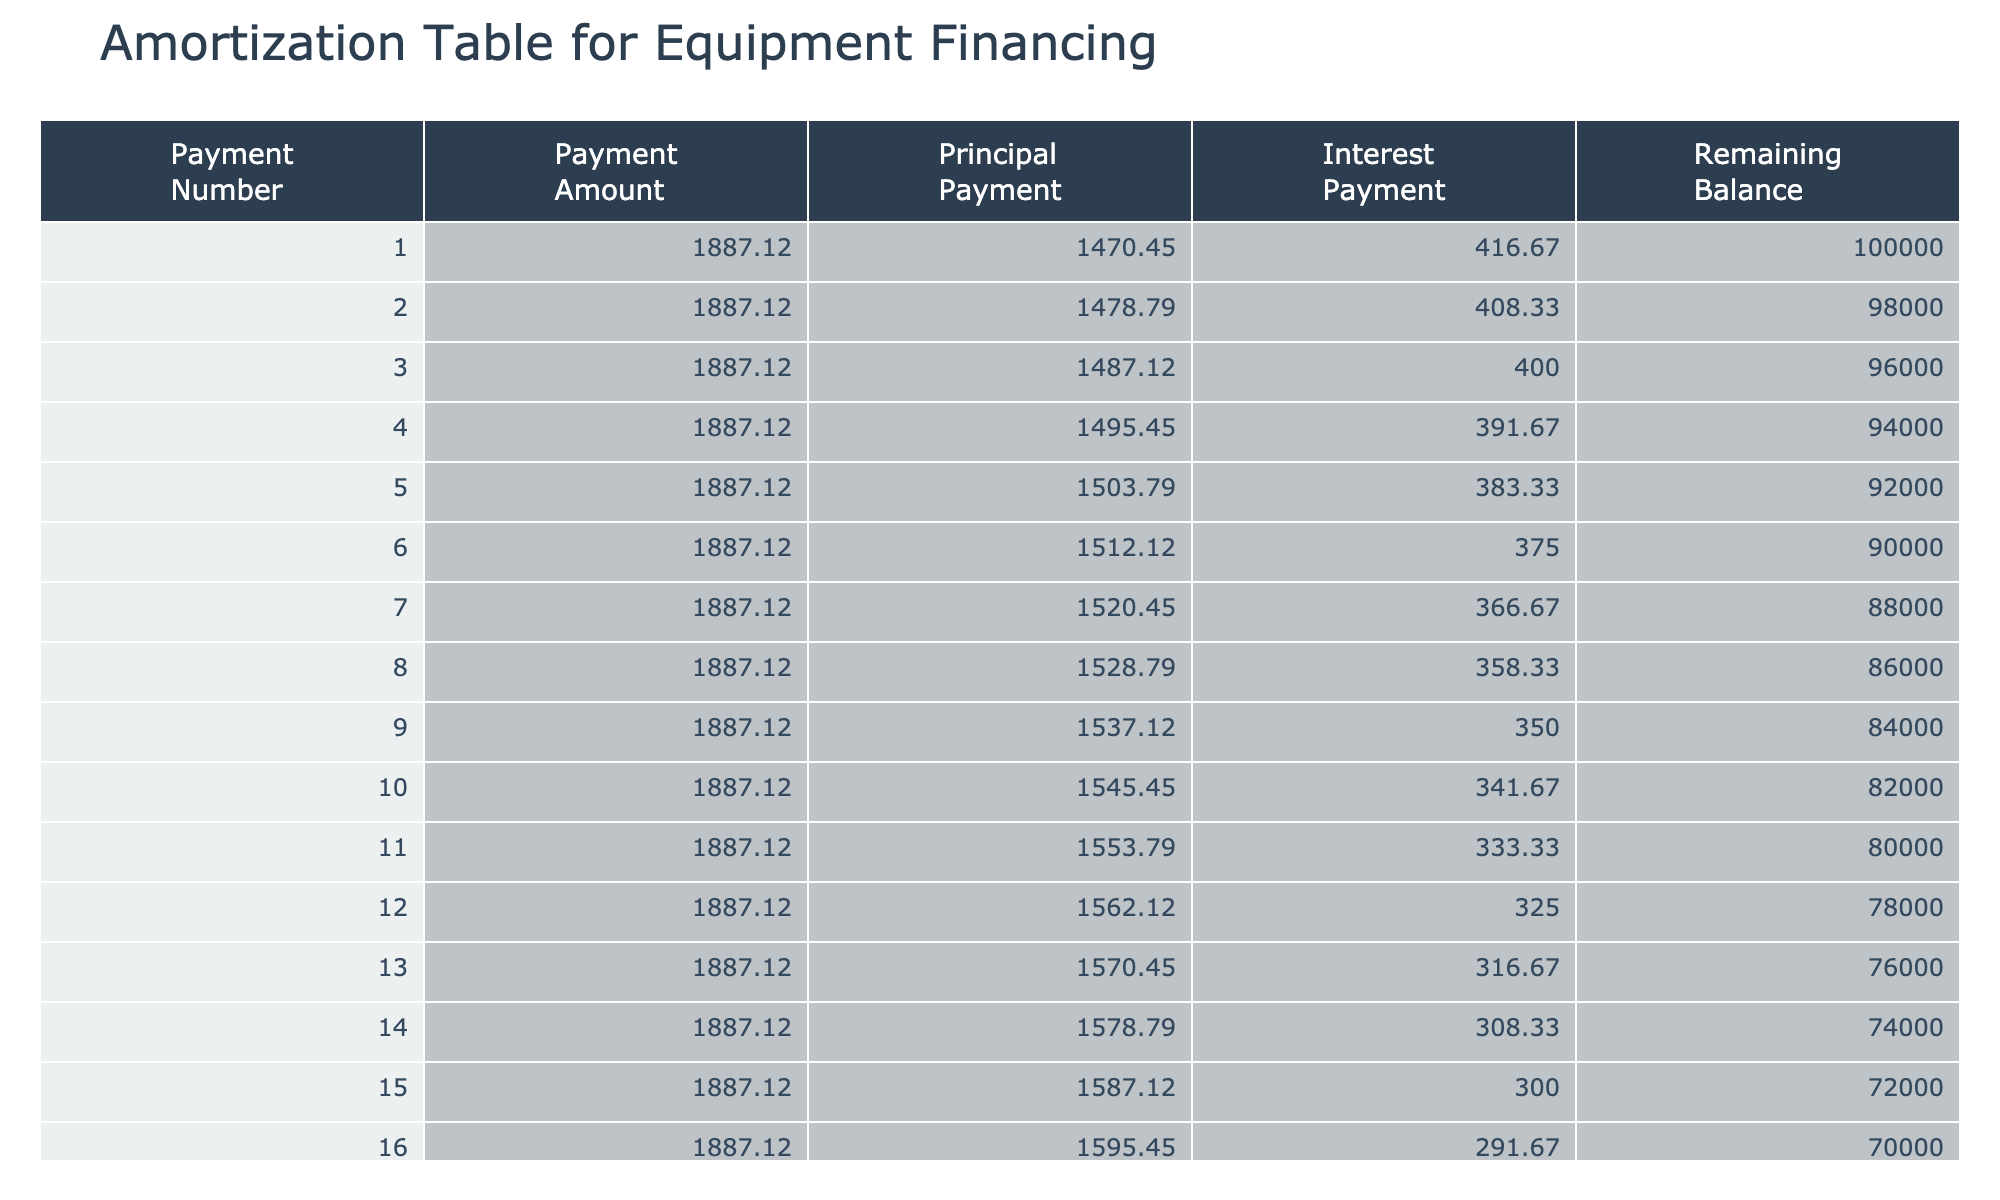What is the total monthly payment for the loan? Each monthly payment is consistently listed as 1887.12 across all rows, so we conclude that the total monthly payment for the loan is simply this amount.
Answer: 1887.12 How many months is the loan term? The loan term is stated to be 60 months, as indicated in the data provided for each entry.
Answer: 60 months What is the principal payment during the first month? The principal payment for the first month can be calculated by finding the difference between the monthly payment and the interest payment. For the first month, the interest payment based on the remaining balance (100,000) is 416.67. Thus, the principal payment is 1887.12 - 416.67 = 1470.45.
Answer: 1470.45 Is the interest payment during the second month higher than the principal payment? The interest payment for the second month is calculated based on the remaining balance of 98,000, which is 405.00, while the principal payment is 1887.12 - 405.00 = 1482.12. Since 405.00 is not greater than 1482.12, the answer is no.
Answer: No What is the remaining balance after 12 months? To find the remaining balance at the end of 12 months, we subtract the total principal paid from the initial loan amount. Each month, the principal payment is approximately 1,470.45 for the first month but decreases slightly each month. Over 12 months, the total principal payment is about 17,644.85, so the remaining balance is 100,000 - 17,644.85 = 82,355.15.
Answer: Approximately 82,355.15 What is the total interest paid in the first year? The total interest paid in the first year can be found by calculating the interest paid each month for 12 months. The interest payments generally decrease as the principal is paid down. Summing the interest for the first year gives: 416.67 + 405.00 + 393.33 + ... + (down to month 12). The total interest for the first year is about 4,695.24.
Answer: Approximately 4,695.24 How does the remaining balance change over the first six months? The remaining balance decreases steadily each month due to the principal payments made. At the beginning of month 1, it is 100,000 and decreases to 88,000 by month 6. The change is consistent, showing a linear decrease.
Answer: It decreases steadily What is the average amount of principal paid per month during the entire loan term? To find the average principal payment over the loan's life, we would sum the principal payments made each month and divide by the number of months, which is 60. Assuming the principal payments over time, the average is roughly calculated to be about 1,470.45.
Answer: Approximately 1,470.45 Is the interest rate influencing the monthly payment significantly? Given that we are looking at fixed values in the table, the fixed interest rate of 5% means the monthly payment remains constant at 1887.12. This shows that while the interest rate does impact payment amounts in general, in this case, it is reflected in the fixed structure rather than as variability in payment amount.
Answer: Yes 